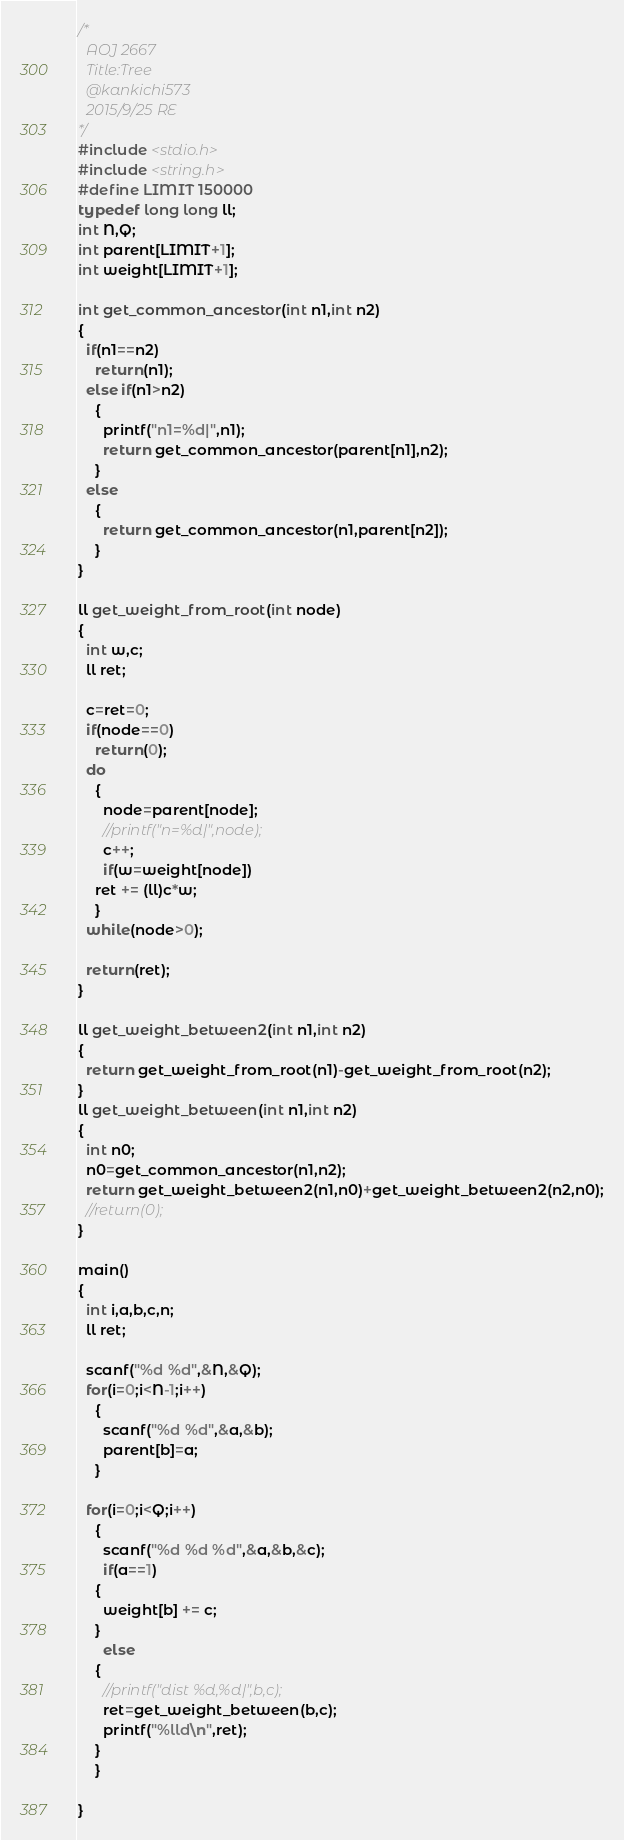<code> <loc_0><loc_0><loc_500><loc_500><_C_>/*
  AOJ 2667
  Title:Tree
  @kankichi573
  2015/9/25 RE
*/
#include <stdio.h>
#include <string.h>
#define LIMIT 150000
typedef long long ll;
int N,Q;
int parent[LIMIT+1];
int weight[LIMIT+1];

int get_common_ancestor(int n1,int n2)
{
  if(n1==n2)
    return(n1);
  else if(n1>n2)
    {
      printf("n1=%d|",n1);
      return get_common_ancestor(parent[n1],n2);
    }
  else
    {
      return get_common_ancestor(n1,parent[n2]);
    }
}

ll get_weight_from_root(int node)
{
  int w,c;
  ll ret;

  c=ret=0;
  if(node==0)
    return(0);
  do
    {
      node=parent[node];
      //printf("n=%d|",node);
      c++;
      if(w=weight[node])
	ret += (ll)c*w;
    }
  while(node>0);

  return(ret);
}

ll get_weight_between2(int n1,int n2)
{
  return get_weight_from_root(n1)-get_weight_from_root(n2);
}
ll get_weight_between(int n1,int n2)
{
  int n0;
  n0=get_common_ancestor(n1,n2);
  return get_weight_between2(n1,n0)+get_weight_between2(n2,n0);
  //return(0);
}

main()
{
  int i,a,b,c,n;
  ll ret;

  scanf("%d %d",&N,&Q);
  for(i=0;i<N-1;i++)
    {
      scanf("%d %d",&a,&b);
      parent[b]=a;
    }

  for(i=0;i<Q;i++)
    {
      scanf("%d %d %d",&a,&b,&c);
      if(a==1)
	{
	  weight[b] += c;
	}
      else
	{
	  //printf("dist %d,%d|",b,c);
	  ret=get_weight_between(b,c);
	  printf("%lld\n",ret);
	}
    }
  
}</code> 